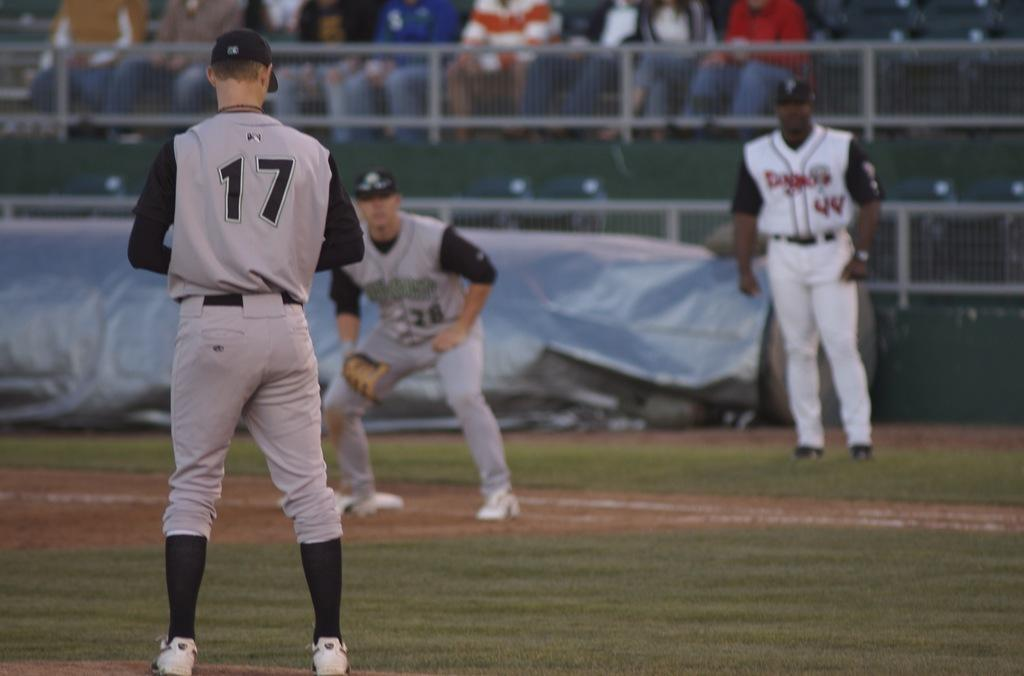<image>
Create a compact narrative representing the image presented. A baseball player with the number 17 on the back of his jersey is playing baseball. 